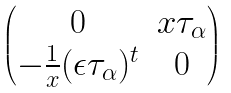Convert formula to latex. <formula><loc_0><loc_0><loc_500><loc_500>\begin{pmatrix} 0 & { x } \tau _ { \alpha } \\ - \frac { 1 } { x } ( \epsilon \tau _ { \alpha } ) ^ { t } & 0 \end{pmatrix}</formula> 